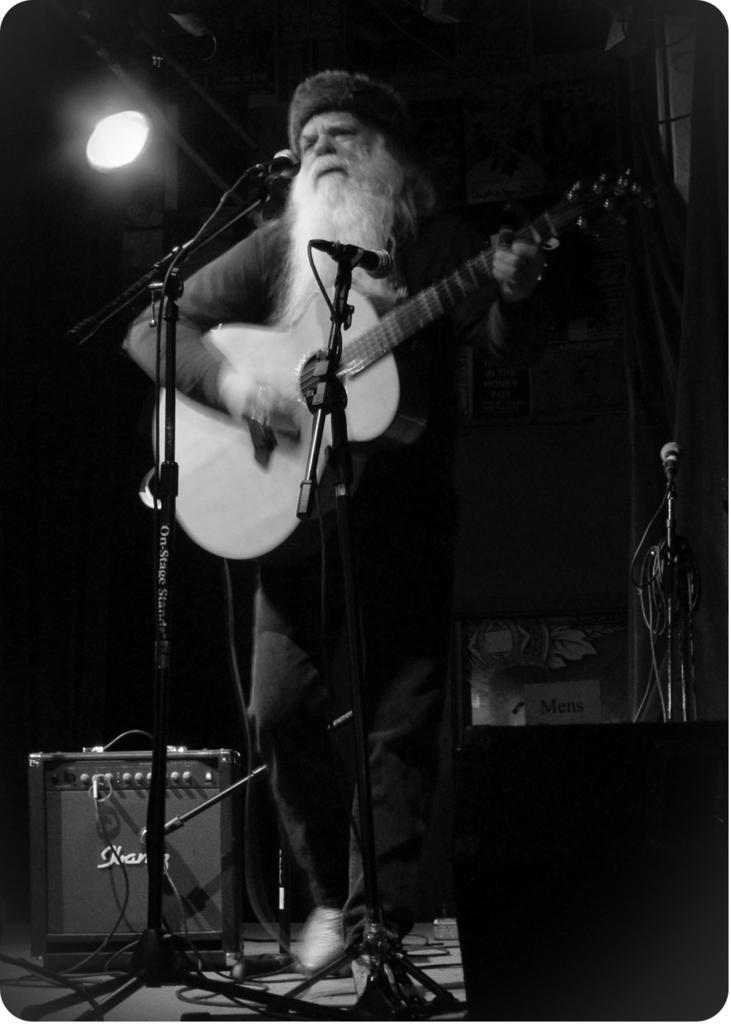In one or two sentences, can you explain what this image depicts? As we can see in the image there is a light, two mics and a man holding guitar. 